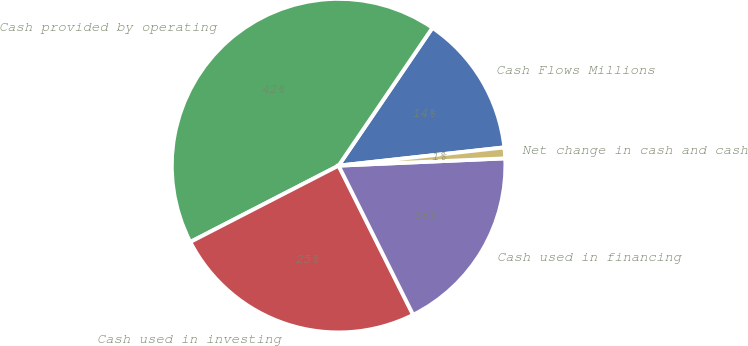Convert chart to OTSL. <chart><loc_0><loc_0><loc_500><loc_500><pie_chart><fcel>Cash Flows Millions<fcel>Cash provided by operating<fcel>Cash used in investing<fcel>Cash used in financing<fcel>Net change in cash and cash<nl><fcel>13.74%<fcel>42.08%<fcel>24.81%<fcel>18.32%<fcel>1.05%<nl></chart> 